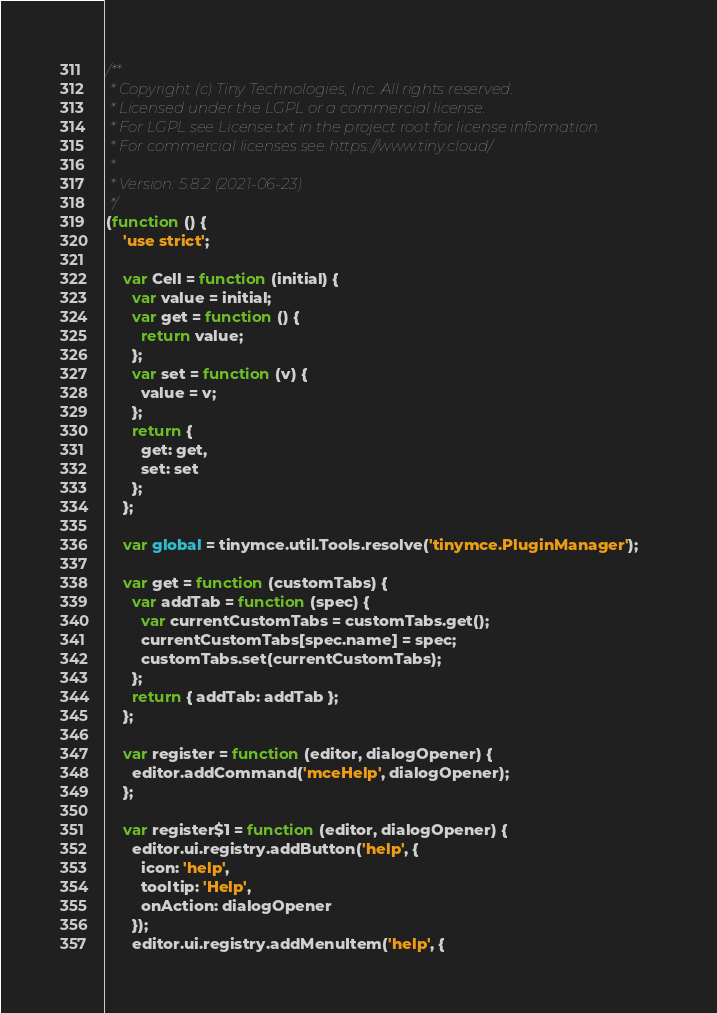Convert code to text. <code><loc_0><loc_0><loc_500><loc_500><_JavaScript_>/**
 * Copyright (c) Tiny Technologies, Inc. All rights reserved.
 * Licensed under the LGPL or a commercial license.
 * For LGPL see License.txt in the project root for license information.
 * For commercial licenses see https://www.tiny.cloud/
 *
 * Version: 5.8.2 (2021-06-23)
 */
(function () {
    'use strict';

    var Cell = function (initial) {
      var value = initial;
      var get = function () {
        return value;
      };
      var set = function (v) {
        value = v;
      };
      return {
        get: get,
        set: set
      };
    };

    var global = tinymce.util.Tools.resolve('tinymce.PluginManager');

    var get = function (customTabs) {
      var addTab = function (spec) {
        var currentCustomTabs = customTabs.get();
        currentCustomTabs[spec.name] = spec;
        customTabs.set(currentCustomTabs);
      };
      return { addTab: addTab };
    };

    var register = function (editor, dialogOpener) {
      editor.addCommand('mceHelp', dialogOpener);
    };

    var register$1 = function (editor, dialogOpener) {
      editor.ui.registry.addButton('help', {
        icon: 'help',
        tooltip: 'Help',
        onAction: dialogOpener
      });
      editor.ui.registry.addMenuItem('help', {</code> 